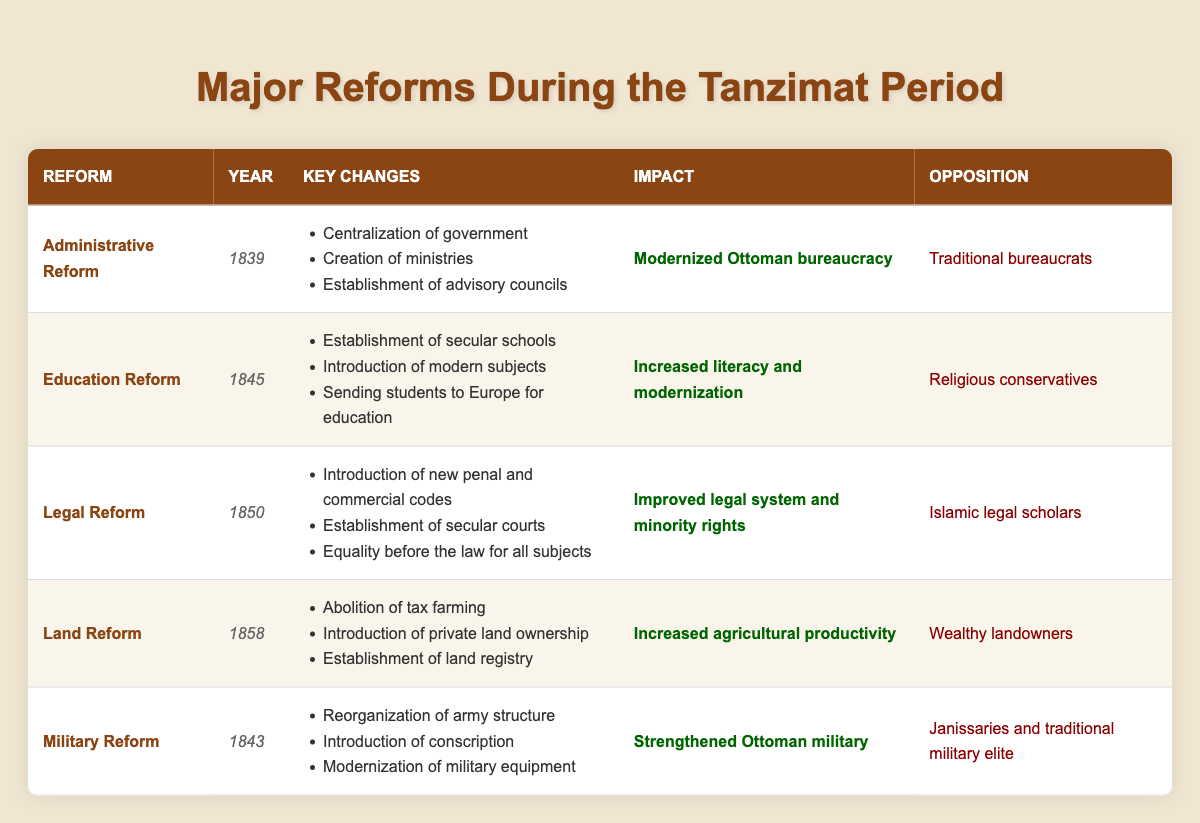What year did the Administrative Reform take place? The table lists the year of each reform in the "Year" column under the Administrative Reform row. It shows 1839 for Administrative Reform.
Answer: 1839 Which reform aimed at increasing literacy and modernization? In the "Impact" column, we find "Increased literacy and modernization" listed under the Education Reform row.
Answer: Education Reform How many reforms were opposed by traditional bureaucrats? By reviewing the "Opposition" column, we see that only the Administrative Reform mentions opposition from traditional bureaucrats, indicating 1 reform.
Answer: 1 What are the key changes introduced in the Legal Reform? In the Legal Reform row, the key changes mentioned include "Introduction of new penal and commercial codes", "Establishment of secular courts", and "Equality before the law for all subjects."
Answer: Introduction of new penal and commercial codes, Establishment of secular courts, Equality before the law for all subjects Which reform occurred between the Military Reform and the Land Reform? The Military Reform took place in 1843 and the Land Reform in 1858. The Education Reform in 1845 is the reform that falls between these two in terms of years.
Answer: Education Reform Were any reforms opposed by religious conservatives? Looking at the "Opposition" column, we see that the Education Reform is opposed by religious conservatives. Therefore, the answer is yes.
Answer: Yes What impact is associated with the Land Reform? The table indicates that the impact of the Land Reform is "Increased agricultural productivity."
Answer: Increased agricultural productivity Which reform introduced private land ownership? By consulting the key changes in the Land Reform row, we find that "Introduction of private land ownership" is listed among its key changes.
Answer: Land Reform How many reforms were introduced in the 1850s? The reforms listed in the 1850s include Legal Reform (1850) and Land Reform (1858), making a total of 2 reforms in that decade.
Answer: 2 